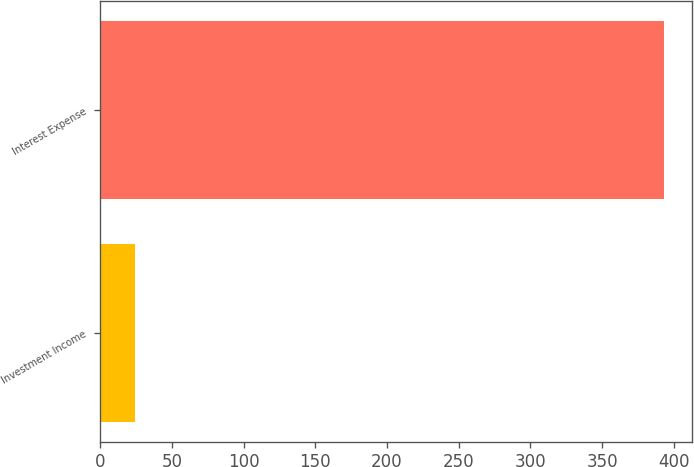Convert chart to OTSL. <chart><loc_0><loc_0><loc_500><loc_500><bar_chart><fcel>Investment Income<fcel>Interest Expense<nl><fcel>24<fcel>393<nl></chart> 